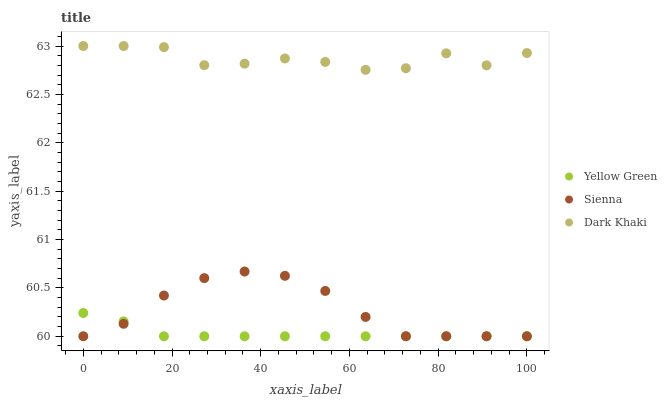Does Yellow Green have the minimum area under the curve?
Answer yes or no. Yes. Does Dark Khaki have the maximum area under the curve?
Answer yes or no. Yes. Does Dark Khaki have the minimum area under the curve?
Answer yes or no. No. Does Yellow Green have the maximum area under the curve?
Answer yes or no. No. Is Yellow Green the smoothest?
Answer yes or no. Yes. Is Dark Khaki the roughest?
Answer yes or no. Yes. Is Dark Khaki the smoothest?
Answer yes or no. No. Is Yellow Green the roughest?
Answer yes or no. No. Does Sienna have the lowest value?
Answer yes or no. Yes. Does Dark Khaki have the lowest value?
Answer yes or no. No. Does Dark Khaki have the highest value?
Answer yes or no. Yes. Does Yellow Green have the highest value?
Answer yes or no. No. Is Yellow Green less than Dark Khaki?
Answer yes or no. Yes. Is Dark Khaki greater than Sienna?
Answer yes or no. Yes. Does Sienna intersect Yellow Green?
Answer yes or no. Yes. Is Sienna less than Yellow Green?
Answer yes or no. No. Is Sienna greater than Yellow Green?
Answer yes or no. No. Does Yellow Green intersect Dark Khaki?
Answer yes or no. No. 